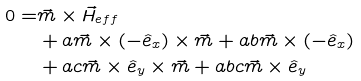Convert formula to latex. <formula><loc_0><loc_0><loc_500><loc_500>0 = & \vec { m } \times \vec { H } _ { e f f } \\ & + a \vec { m } \times ( - \hat { e } _ { x } ) \times \vec { m } + a b \vec { m } \times ( - \hat { e } _ { x } ) \\ & + a c \vec { m } \times \hat { e } _ { y } \times \vec { m } + a b c \vec { m } \times \hat { e } _ { y }</formula> 